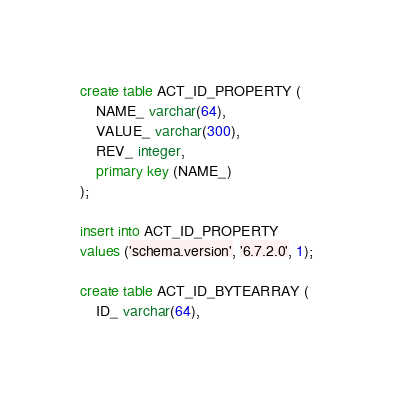<code> <loc_0><loc_0><loc_500><loc_500><_SQL_>create table ACT_ID_PROPERTY (
    NAME_ varchar(64),
    VALUE_ varchar(300),
    REV_ integer,
    primary key (NAME_)
);

insert into ACT_ID_PROPERTY
values ('schema.version', '6.7.2.0', 1);

create table ACT_ID_BYTEARRAY (
    ID_ varchar(64),</code> 